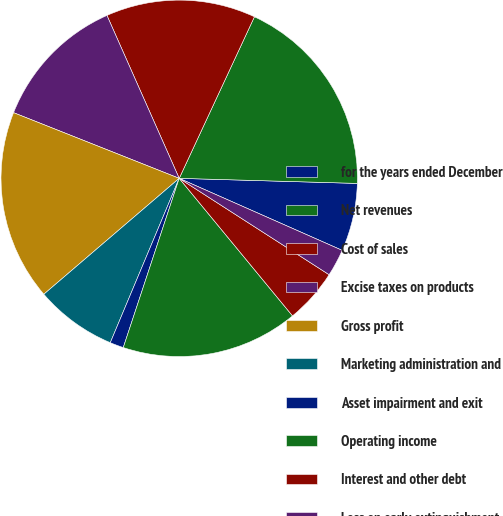<chart> <loc_0><loc_0><loc_500><loc_500><pie_chart><fcel>for the years ended December<fcel>Net revenues<fcel>Cost of sales<fcel>Excise taxes on products<fcel>Gross profit<fcel>Marketing administration and<fcel>Asset impairment and exit<fcel>Operating income<fcel>Interest and other debt<fcel>Loss on early extinguishment<nl><fcel>6.17%<fcel>18.52%<fcel>13.58%<fcel>12.35%<fcel>17.28%<fcel>7.41%<fcel>1.24%<fcel>16.05%<fcel>4.94%<fcel>2.47%<nl></chart> 